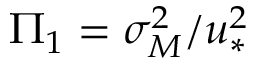<formula> <loc_0><loc_0><loc_500><loc_500>\Pi _ { 1 } = \sigma _ { M } ^ { 2 } / u _ { * } ^ { 2 }</formula> 